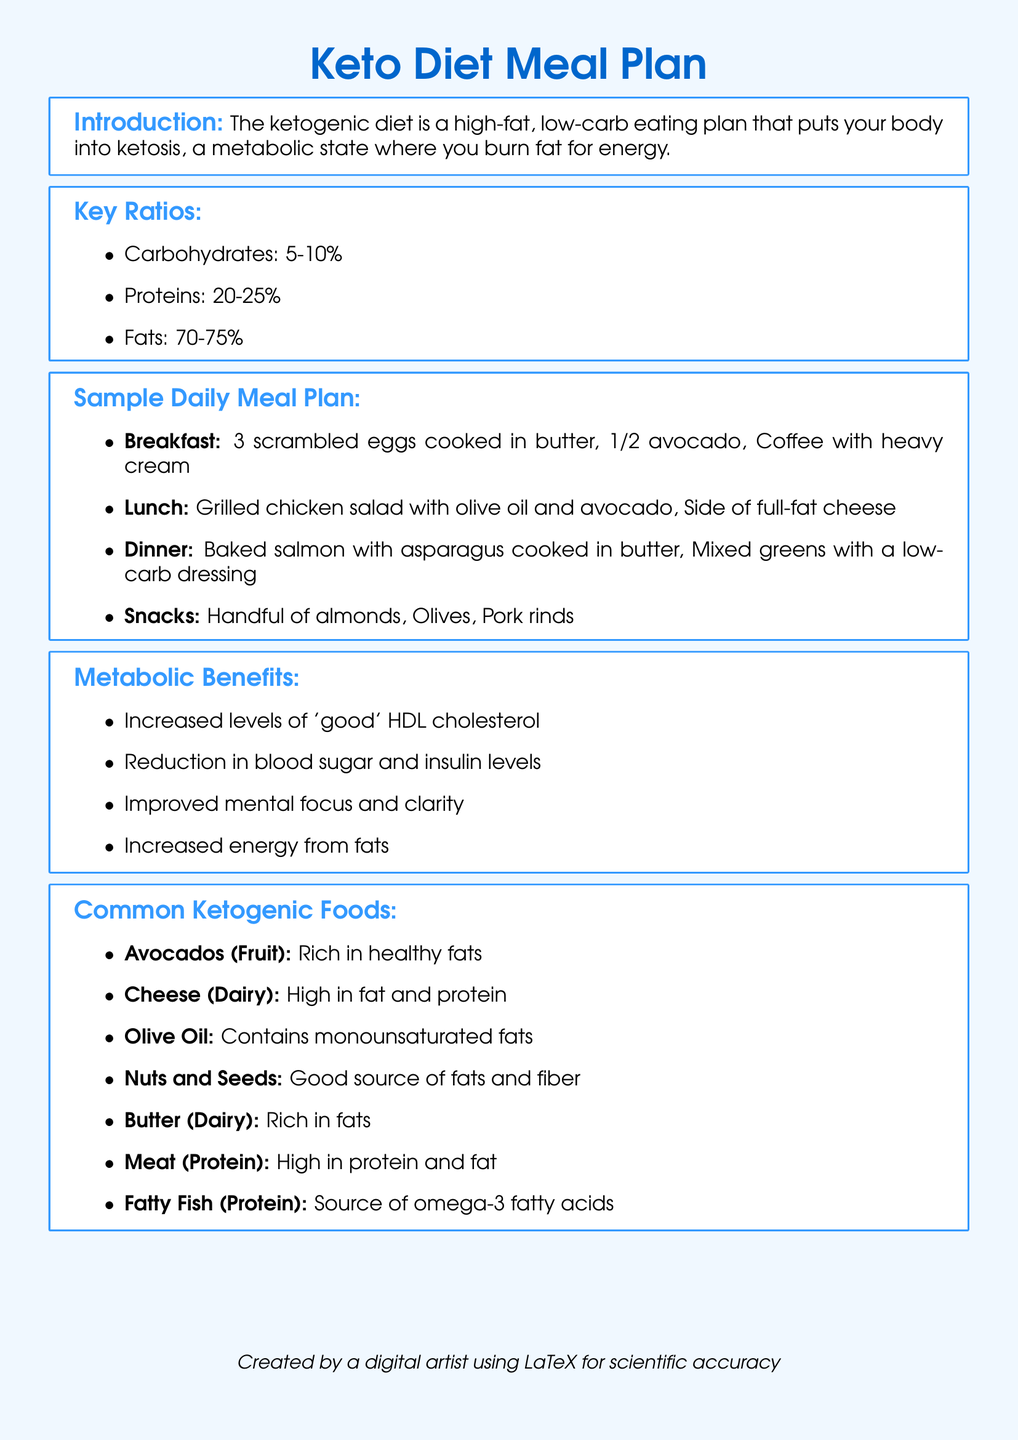What are the key macronutrient ratios in the keto diet? The key macronutrient ratios in the keto diet are specified in the document, which outlines carbohydrates, proteins, and fats.
Answer: Carbohydrates: 5-10%, Proteins: 20-25%, Fats: 70-75% What is a common breakfast option in the meal plan? The document provides specific examples of meals for each part of the day, including breakfast.
Answer: 3 scrambled eggs cooked in butter, 1/2 avocado, Coffee with heavy cream What benefit does increased HDL cholesterol provide? The document lists metabolic benefits, including the specific mention of "good" HDL cholesterol and its positive impact.
Answer: Increased levels of 'good' HDL cholesterol Which food is rich in healthy fats as per the document? The document includes a list of common ketogenic foods, specifying which foods are rich in healthy fats.
Answer: Avocados What percentage of the daily intake should be fat on a ketogenic diet? The document specifies the percentage of daily intake that should come from fat, which is key to a keto diet.
Answer: 70-75% Why might someone choose to follow a ketogenic diet? The document outlines various metabolic benefits, giving reasons why someone might consider adopting this diet.
Answer: Improved mental focus and clarity 